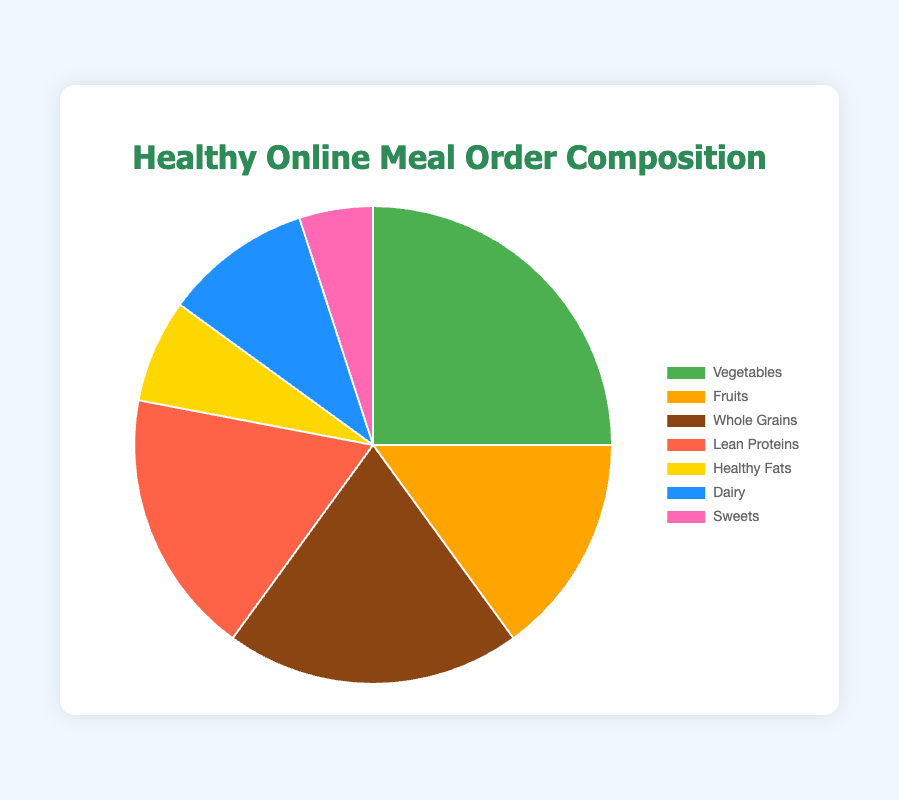What food group makes up the largest proportion of online meal orders? The figure shows a pie chart with different sections. The section labeled "Vegetables" is the largest, indicating it makes up the largest proportion.
Answer: Vegetables Which two food groups combined make up more than 40% of the orders? From the pie chart, "Vegetables" make up 25% and "Whole Grains" make up 20%. Adding these proportions gives 25% + 20% = 45%, which is more than 40%.
Answer: Vegetables and Whole Grains Are there more online orders containing lean proteins or dairy? The pie chart indicates that "Lean Proteins" make up 18% of the orders and "Dairy" makes up 10%. Since 18% > 10%, there are more orders containing lean proteins.
Answer: Lean Proteins What is the difference in the proportion of orders containing fruits and healthy fats? The pie chart shows that "Fruits" make up 15% of the orders while "Healthy Fats" make up 7%. The difference is 15% - 7% = 8%.
Answer: 8% Which food group is represented by the smallest section of the pie chart? The smallest section in the pie chart is labeled "Sweets", indicating it makes up the smallest proportion of the orders.
Answer: Sweets Calculate the combined proportion of online meal orders containing dairy and healthy fats. From the pie chart, "Dairy" makes up 10% and "Healthy Fats" makes up 7%. The combined proportion is 10% + 7% = 17%.
Answer: 17% By how much does the proportion of vegetable orders exceed that of sweets orders? In the pie chart, "Vegetables" make up 25% and "Sweets" make up 5%. The excess amount is 25% - 5% = 20%.
Answer: 20% What is the proportion of orders containing vegetables in relation to the total number of orders excluding sweets? Excluding "Sweets" (5%), the remaining proportion is 100% - 5% = 95%. Vegetables are 25% of the total. Thus, the proportion of vegetables in relation to the total excluding sweets is 25 / 95 = 0.263 or 26.3%.
Answer: 26.3% 